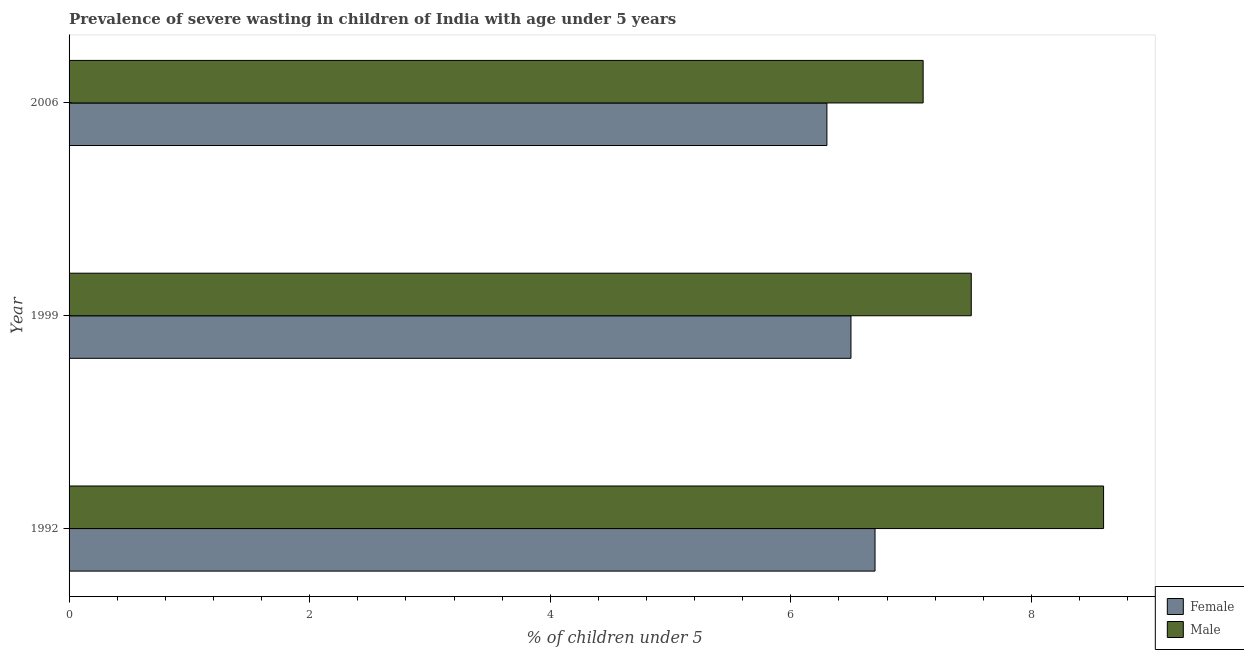How many different coloured bars are there?
Give a very brief answer. 2. Are the number of bars on each tick of the Y-axis equal?
Offer a very short reply. Yes. How many bars are there on the 3rd tick from the top?
Provide a succinct answer. 2. In how many cases, is the number of bars for a given year not equal to the number of legend labels?
Ensure brevity in your answer.  0. What is the percentage of undernourished male children in 1999?
Offer a terse response. 7.5. Across all years, what is the maximum percentage of undernourished male children?
Ensure brevity in your answer.  8.6. Across all years, what is the minimum percentage of undernourished female children?
Make the answer very short. 6.3. In which year was the percentage of undernourished female children maximum?
Your answer should be very brief. 1992. In which year was the percentage of undernourished female children minimum?
Give a very brief answer. 2006. What is the total percentage of undernourished male children in the graph?
Provide a succinct answer. 23.2. What is the difference between the percentage of undernourished female children in 1999 and that in 2006?
Your answer should be very brief. 0.2. What is the difference between the percentage of undernourished female children in 2006 and the percentage of undernourished male children in 1992?
Your answer should be very brief. -2.3. What is the average percentage of undernourished male children per year?
Offer a terse response. 7.73. In the year 1999, what is the difference between the percentage of undernourished female children and percentage of undernourished male children?
Provide a succinct answer. -1. What is the ratio of the percentage of undernourished male children in 1992 to that in 1999?
Offer a terse response. 1.15. Is the percentage of undernourished female children in 1992 less than that in 1999?
Keep it short and to the point. No. What is the difference between the highest and the second highest percentage of undernourished male children?
Give a very brief answer. 1.1. What is the difference between the highest and the lowest percentage of undernourished female children?
Ensure brevity in your answer.  0.4. How many bars are there?
Your answer should be very brief. 6. How many years are there in the graph?
Provide a succinct answer. 3. What is the difference between two consecutive major ticks on the X-axis?
Provide a short and direct response. 2. Are the values on the major ticks of X-axis written in scientific E-notation?
Offer a very short reply. No. Does the graph contain any zero values?
Provide a succinct answer. No. How many legend labels are there?
Provide a succinct answer. 2. How are the legend labels stacked?
Your answer should be compact. Vertical. What is the title of the graph?
Give a very brief answer. Prevalence of severe wasting in children of India with age under 5 years. Does "% of gross capital formation" appear as one of the legend labels in the graph?
Your answer should be compact. No. What is the label or title of the X-axis?
Give a very brief answer.  % of children under 5. What is the  % of children under 5 in Female in 1992?
Give a very brief answer. 6.7. What is the  % of children under 5 of Male in 1992?
Your answer should be very brief. 8.6. What is the  % of children under 5 of Male in 1999?
Your answer should be compact. 7.5. What is the  % of children under 5 of Female in 2006?
Offer a very short reply. 6.3. What is the  % of children under 5 in Male in 2006?
Ensure brevity in your answer.  7.1. Across all years, what is the maximum  % of children under 5 of Female?
Offer a very short reply. 6.7. Across all years, what is the maximum  % of children under 5 of Male?
Your answer should be very brief. 8.6. Across all years, what is the minimum  % of children under 5 of Female?
Offer a terse response. 6.3. Across all years, what is the minimum  % of children under 5 in Male?
Keep it short and to the point. 7.1. What is the total  % of children under 5 of Female in the graph?
Give a very brief answer. 19.5. What is the total  % of children under 5 of Male in the graph?
Your answer should be compact. 23.2. What is the difference between the  % of children under 5 of Male in 1992 and that in 2006?
Provide a succinct answer. 1.5. What is the difference between the  % of children under 5 of Female in 1999 and that in 2006?
Offer a very short reply. 0.2. What is the difference between the  % of children under 5 in Female in 1992 and the  % of children under 5 in Male in 1999?
Your answer should be very brief. -0.8. What is the difference between the  % of children under 5 of Female in 1992 and the  % of children under 5 of Male in 2006?
Make the answer very short. -0.4. What is the average  % of children under 5 of Female per year?
Ensure brevity in your answer.  6.5. What is the average  % of children under 5 in Male per year?
Provide a short and direct response. 7.73. In the year 1992, what is the difference between the  % of children under 5 of Female and  % of children under 5 of Male?
Provide a succinct answer. -1.9. In the year 2006, what is the difference between the  % of children under 5 in Female and  % of children under 5 in Male?
Give a very brief answer. -0.8. What is the ratio of the  % of children under 5 in Female in 1992 to that in 1999?
Keep it short and to the point. 1.03. What is the ratio of the  % of children under 5 in Male in 1992 to that in 1999?
Your answer should be very brief. 1.15. What is the ratio of the  % of children under 5 in Female in 1992 to that in 2006?
Make the answer very short. 1.06. What is the ratio of the  % of children under 5 in Male in 1992 to that in 2006?
Your response must be concise. 1.21. What is the ratio of the  % of children under 5 of Female in 1999 to that in 2006?
Offer a terse response. 1.03. What is the ratio of the  % of children under 5 in Male in 1999 to that in 2006?
Offer a terse response. 1.06. What is the difference between the highest and the second highest  % of children under 5 of Female?
Provide a short and direct response. 0.2. What is the difference between the highest and the second highest  % of children under 5 of Male?
Offer a very short reply. 1.1. What is the difference between the highest and the lowest  % of children under 5 of Male?
Ensure brevity in your answer.  1.5. 